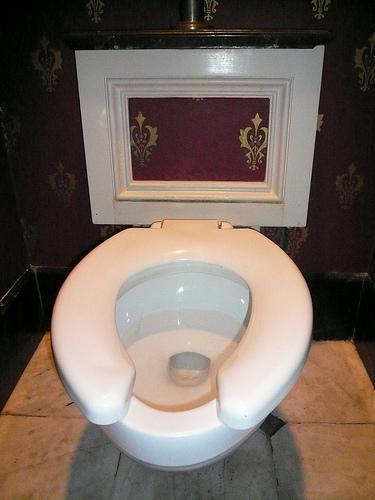How many toilets are seen?
Give a very brief answer. 1. 